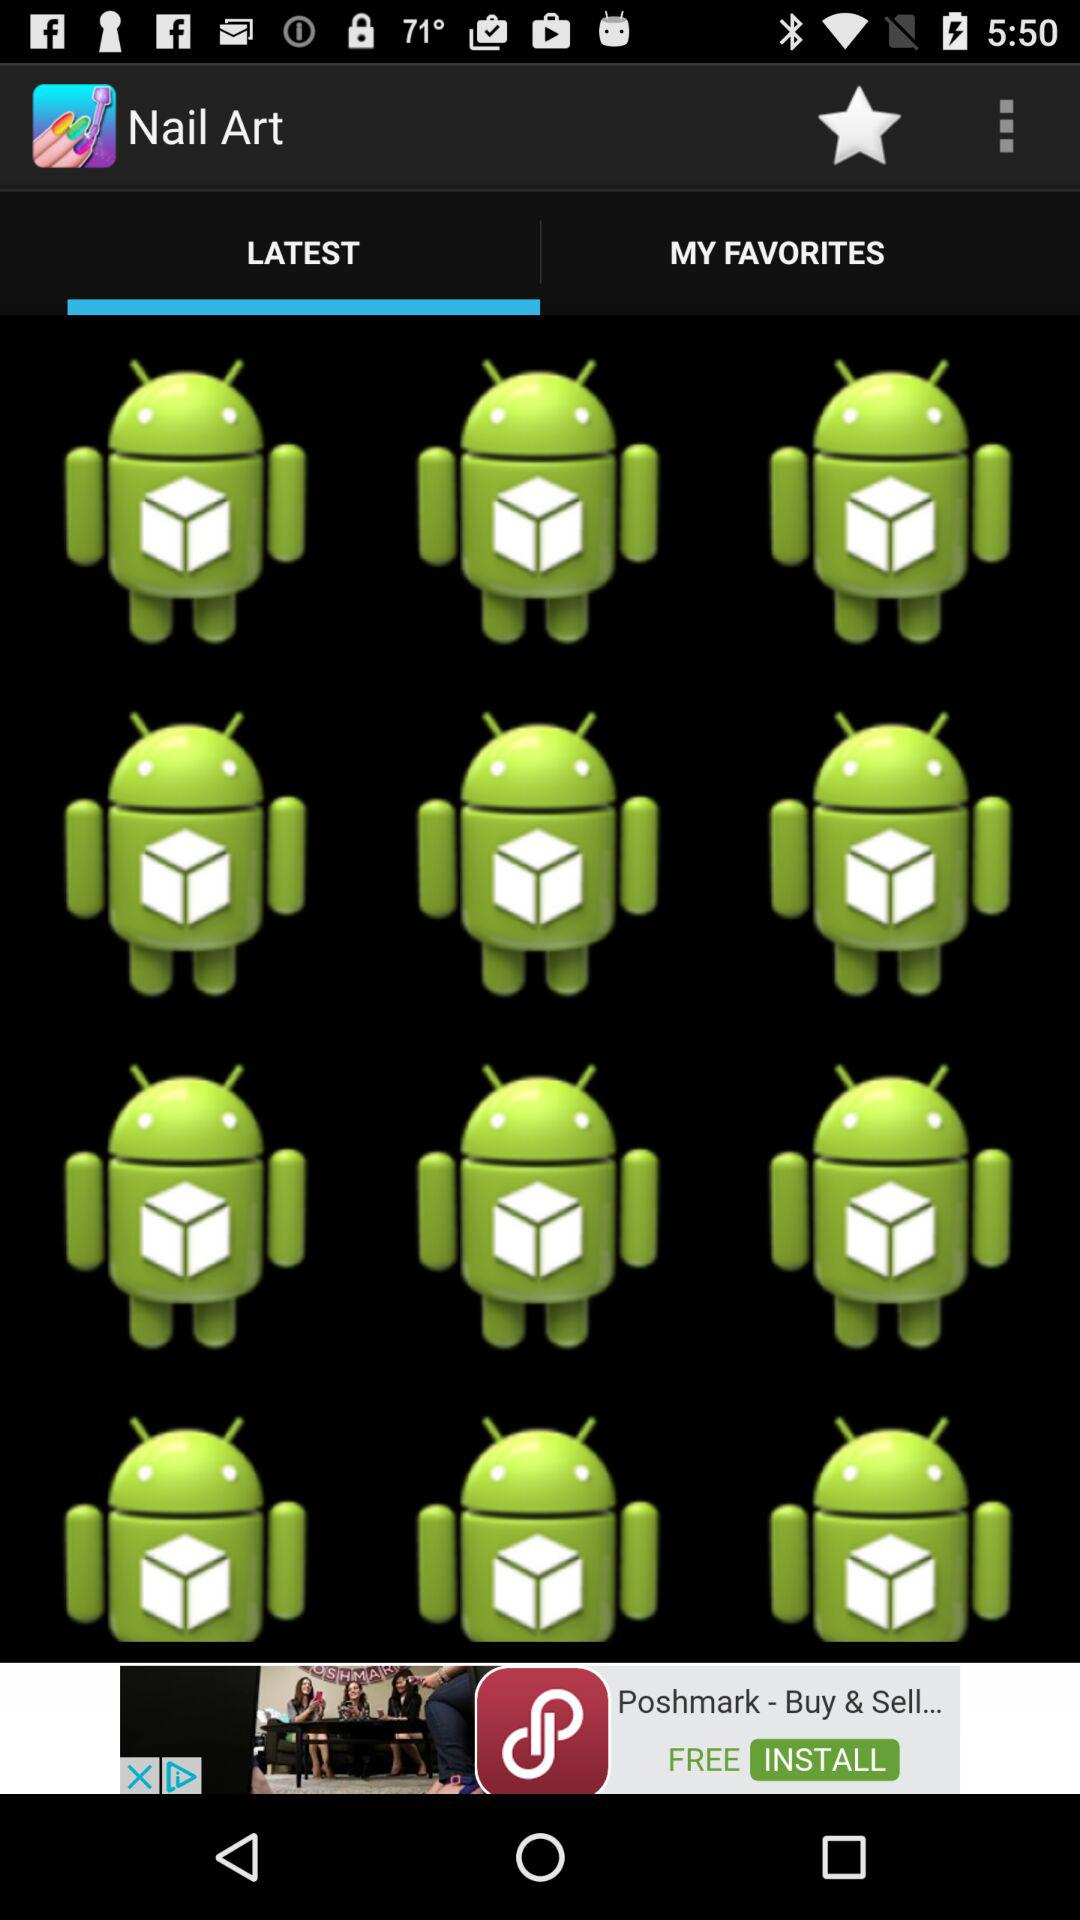Which option is selected? The selected option is "LATEST". 